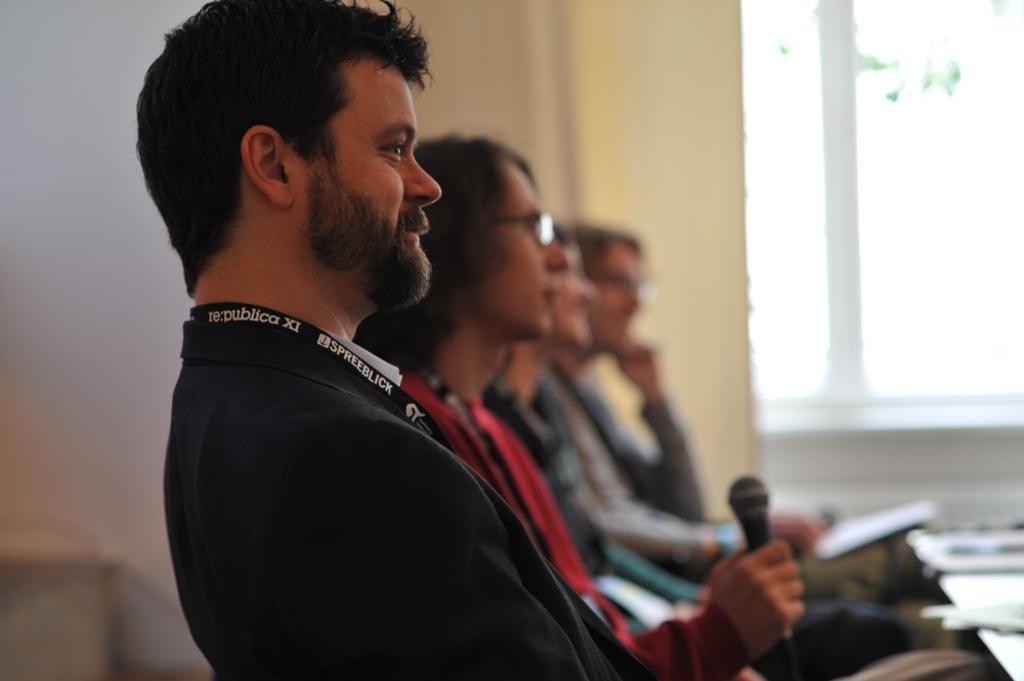How would you summarize this image in a sentence or two? This picture shows few people seated on the chairs and we see a human holding microphone in the hand and we see papers on the table and a window with a curtain and couple of them wore spectacles on the faces. 